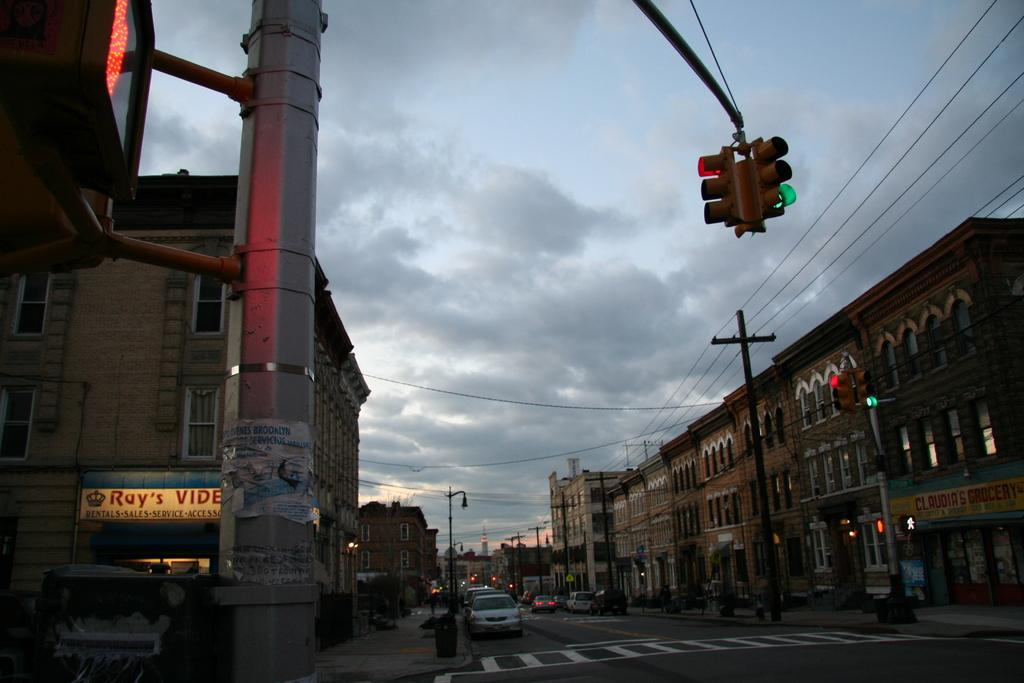<image>
Relay a brief, clear account of the picture shown. A city corner at dusk has a sign that says Ray's Video. 